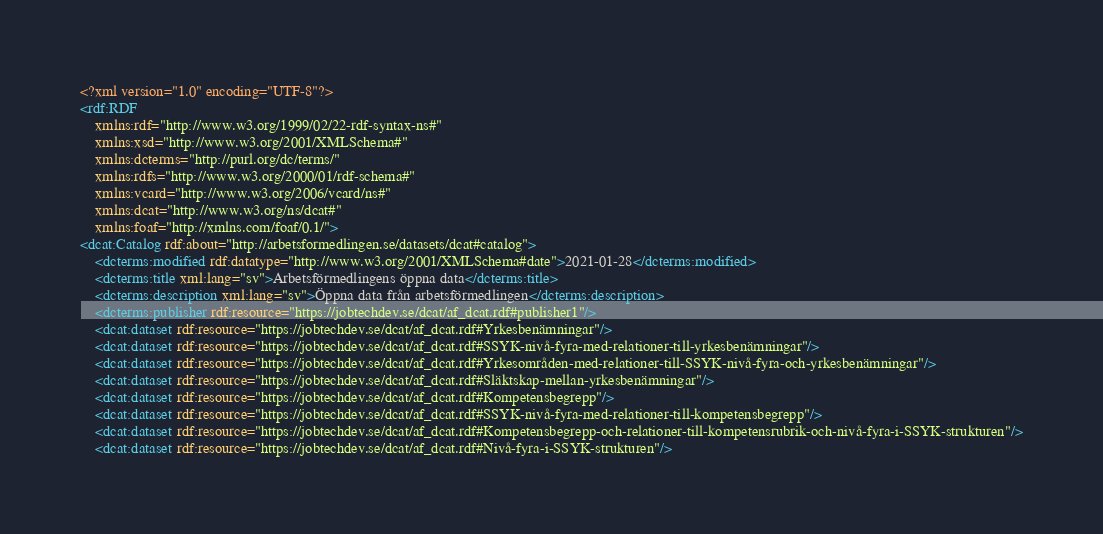Convert code to text. <code><loc_0><loc_0><loc_500><loc_500><_XML_><?xml version="1.0" encoding="UTF-8"?>
<rdf:RDF
	xmlns:rdf="http://www.w3.org/1999/02/22-rdf-syntax-ns#"
	xmlns:xsd="http://www.w3.org/2001/XMLSchema#"
	xmlns:dcterms="http://purl.org/dc/terms/"
	xmlns:rdfs="http://www.w3.org/2000/01/rdf-schema#"
	xmlns:vcard="http://www.w3.org/2006/vcard/ns#"
	xmlns:dcat="http://www.w3.org/ns/dcat#"
	xmlns:foaf="http://xmlns.com/foaf/0.1/">
<dcat:Catalog rdf:about="http://arbetsformedlingen.se/datasets/dcat#catalog">
	<dcterms:modified rdf:datatype="http://www.w3.org/2001/XMLSchema#date">2021-01-28</dcterms:modified>
	<dcterms:title xml:lang="sv">Arbetsförmedlingens öppna data</dcterms:title>
	<dcterms:description xml:lang="sv">Öppna data från arbetsförmedlingen</dcterms:description>
	<dcterms:publisher rdf:resource="https://jobtechdev.se/dcat/af_dcat.rdf#publisher1"/>
	<dcat:dataset rdf:resource="https://jobtechdev.se/dcat/af_dcat.rdf#Yrkesbenämningar"/>
	<dcat:dataset rdf:resource="https://jobtechdev.se/dcat/af_dcat.rdf#SSYK-nivå-fyra-med-relationer-till-yrkesbenämningar"/>
	<dcat:dataset rdf:resource="https://jobtechdev.se/dcat/af_dcat.rdf#Yrkesområden-med-relationer-till-SSYK-nivå-fyra-och-yrkesbenämningar"/>
	<dcat:dataset rdf:resource="https://jobtechdev.se/dcat/af_dcat.rdf#Släktskap-mellan-yrkesbenämningar"/>
	<dcat:dataset rdf:resource="https://jobtechdev.se/dcat/af_dcat.rdf#Kompetensbegrepp"/>
	<dcat:dataset rdf:resource="https://jobtechdev.se/dcat/af_dcat.rdf#SSYK-nivå-fyra-med-relationer-till-kompetensbegrepp"/>
	<dcat:dataset rdf:resource="https://jobtechdev.se/dcat/af_dcat.rdf#Kompetensbegrepp-och-relationer-till-kompetensrubrik-och-nivå-fyra-i-SSYK-strukturen"/>
	<dcat:dataset rdf:resource="https://jobtechdev.se/dcat/af_dcat.rdf#Nivå-fyra-i-SSYK-strukturen"/></code> 